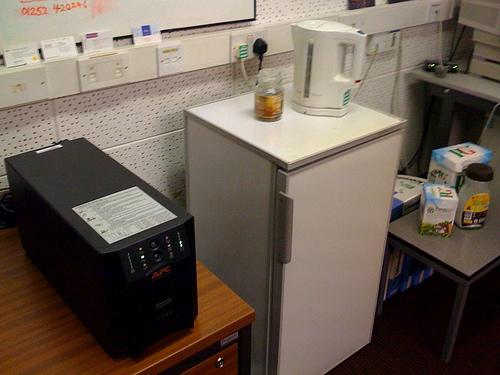What is the appliance under the coffee maker?
Write a very short answer. Refrigerator. What is the coffee maker for?
Write a very short answer. Making coffee. How many things are plugged in?
Be succinct. 2. Was the picture taken in a house?
Give a very brief answer. No. 